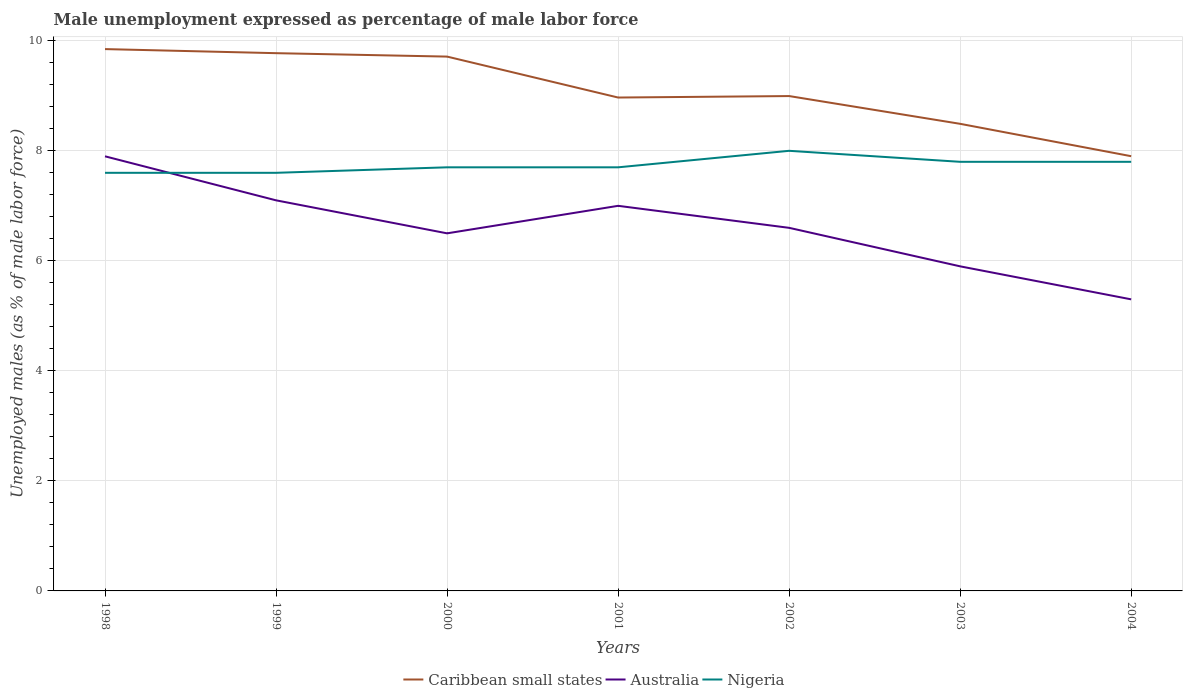How many different coloured lines are there?
Offer a terse response. 3. Is the number of lines equal to the number of legend labels?
Your response must be concise. Yes. Across all years, what is the maximum unemployment in males in in Nigeria?
Provide a short and direct response. 7.6. What is the total unemployment in males in in Caribbean small states in the graph?
Offer a very short reply. 1.22. What is the difference between the highest and the second highest unemployment in males in in Australia?
Offer a very short reply. 2.6. What is the difference between the highest and the lowest unemployment in males in in Nigeria?
Keep it short and to the point. 3. Is the unemployment in males in in Australia strictly greater than the unemployment in males in in Nigeria over the years?
Provide a succinct answer. No. How many lines are there?
Provide a short and direct response. 3. How many years are there in the graph?
Your response must be concise. 7. What is the difference between two consecutive major ticks on the Y-axis?
Provide a succinct answer. 2. Are the values on the major ticks of Y-axis written in scientific E-notation?
Make the answer very short. No. Does the graph contain any zero values?
Provide a short and direct response. No. Where does the legend appear in the graph?
Offer a terse response. Bottom center. How many legend labels are there?
Offer a very short reply. 3. What is the title of the graph?
Make the answer very short. Male unemployment expressed as percentage of male labor force. Does "Uzbekistan" appear as one of the legend labels in the graph?
Make the answer very short. No. What is the label or title of the Y-axis?
Make the answer very short. Unemployed males (as % of male labor force). What is the Unemployed males (as % of male labor force) in Caribbean small states in 1998?
Provide a succinct answer. 9.85. What is the Unemployed males (as % of male labor force) in Australia in 1998?
Provide a succinct answer. 7.9. What is the Unemployed males (as % of male labor force) in Nigeria in 1998?
Offer a terse response. 7.6. What is the Unemployed males (as % of male labor force) of Caribbean small states in 1999?
Keep it short and to the point. 9.77. What is the Unemployed males (as % of male labor force) of Australia in 1999?
Ensure brevity in your answer.  7.1. What is the Unemployed males (as % of male labor force) in Nigeria in 1999?
Your answer should be very brief. 7.6. What is the Unemployed males (as % of male labor force) in Caribbean small states in 2000?
Your answer should be very brief. 9.71. What is the Unemployed males (as % of male labor force) of Australia in 2000?
Provide a succinct answer. 6.5. What is the Unemployed males (as % of male labor force) in Nigeria in 2000?
Offer a terse response. 7.7. What is the Unemployed males (as % of male labor force) of Caribbean small states in 2001?
Your answer should be very brief. 8.97. What is the Unemployed males (as % of male labor force) of Nigeria in 2001?
Your answer should be compact. 7.7. What is the Unemployed males (as % of male labor force) of Caribbean small states in 2002?
Your response must be concise. 9. What is the Unemployed males (as % of male labor force) of Australia in 2002?
Provide a succinct answer. 6.6. What is the Unemployed males (as % of male labor force) of Nigeria in 2002?
Offer a very short reply. 8. What is the Unemployed males (as % of male labor force) of Caribbean small states in 2003?
Make the answer very short. 8.49. What is the Unemployed males (as % of male labor force) of Australia in 2003?
Offer a very short reply. 5.9. What is the Unemployed males (as % of male labor force) of Nigeria in 2003?
Provide a short and direct response. 7.8. What is the Unemployed males (as % of male labor force) in Caribbean small states in 2004?
Offer a terse response. 7.9. What is the Unemployed males (as % of male labor force) in Australia in 2004?
Offer a very short reply. 5.3. What is the Unemployed males (as % of male labor force) in Nigeria in 2004?
Give a very brief answer. 7.8. Across all years, what is the maximum Unemployed males (as % of male labor force) in Caribbean small states?
Provide a succinct answer. 9.85. Across all years, what is the maximum Unemployed males (as % of male labor force) of Australia?
Your answer should be compact. 7.9. Across all years, what is the maximum Unemployed males (as % of male labor force) in Nigeria?
Ensure brevity in your answer.  8. Across all years, what is the minimum Unemployed males (as % of male labor force) of Caribbean small states?
Offer a terse response. 7.9. Across all years, what is the minimum Unemployed males (as % of male labor force) of Australia?
Ensure brevity in your answer.  5.3. Across all years, what is the minimum Unemployed males (as % of male labor force) in Nigeria?
Your answer should be compact. 7.6. What is the total Unemployed males (as % of male labor force) of Caribbean small states in the graph?
Your answer should be very brief. 63.69. What is the total Unemployed males (as % of male labor force) in Australia in the graph?
Keep it short and to the point. 46.3. What is the total Unemployed males (as % of male labor force) in Nigeria in the graph?
Keep it short and to the point. 54.2. What is the difference between the Unemployed males (as % of male labor force) in Caribbean small states in 1998 and that in 1999?
Your answer should be very brief. 0.07. What is the difference between the Unemployed males (as % of male labor force) in Caribbean small states in 1998 and that in 2000?
Provide a short and direct response. 0.14. What is the difference between the Unemployed males (as % of male labor force) in Australia in 1998 and that in 2000?
Give a very brief answer. 1.4. What is the difference between the Unemployed males (as % of male labor force) of Caribbean small states in 1998 and that in 2001?
Make the answer very short. 0.88. What is the difference between the Unemployed males (as % of male labor force) of Australia in 1998 and that in 2001?
Your answer should be compact. 0.9. What is the difference between the Unemployed males (as % of male labor force) in Nigeria in 1998 and that in 2001?
Ensure brevity in your answer.  -0.1. What is the difference between the Unemployed males (as % of male labor force) of Caribbean small states in 1998 and that in 2002?
Your answer should be very brief. 0.85. What is the difference between the Unemployed males (as % of male labor force) in Australia in 1998 and that in 2002?
Ensure brevity in your answer.  1.3. What is the difference between the Unemployed males (as % of male labor force) in Nigeria in 1998 and that in 2002?
Your response must be concise. -0.4. What is the difference between the Unemployed males (as % of male labor force) of Caribbean small states in 1998 and that in 2003?
Ensure brevity in your answer.  1.36. What is the difference between the Unemployed males (as % of male labor force) of Caribbean small states in 1998 and that in 2004?
Make the answer very short. 1.95. What is the difference between the Unemployed males (as % of male labor force) in Caribbean small states in 1999 and that in 2000?
Make the answer very short. 0.06. What is the difference between the Unemployed males (as % of male labor force) in Nigeria in 1999 and that in 2000?
Your answer should be very brief. -0.1. What is the difference between the Unemployed males (as % of male labor force) in Caribbean small states in 1999 and that in 2001?
Your response must be concise. 0.81. What is the difference between the Unemployed males (as % of male labor force) of Australia in 1999 and that in 2001?
Offer a terse response. 0.1. What is the difference between the Unemployed males (as % of male labor force) of Nigeria in 1999 and that in 2001?
Your response must be concise. -0.1. What is the difference between the Unemployed males (as % of male labor force) in Caribbean small states in 1999 and that in 2002?
Your answer should be compact. 0.78. What is the difference between the Unemployed males (as % of male labor force) in Nigeria in 1999 and that in 2002?
Ensure brevity in your answer.  -0.4. What is the difference between the Unemployed males (as % of male labor force) of Caribbean small states in 1999 and that in 2003?
Ensure brevity in your answer.  1.28. What is the difference between the Unemployed males (as % of male labor force) in Caribbean small states in 1999 and that in 2004?
Give a very brief answer. 1.87. What is the difference between the Unemployed males (as % of male labor force) of Australia in 1999 and that in 2004?
Give a very brief answer. 1.8. What is the difference between the Unemployed males (as % of male labor force) of Nigeria in 1999 and that in 2004?
Ensure brevity in your answer.  -0.2. What is the difference between the Unemployed males (as % of male labor force) of Caribbean small states in 2000 and that in 2001?
Ensure brevity in your answer.  0.74. What is the difference between the Unemployed males (as % of male labor force) in Australia in 2000 and that in 2001?
Your answer should be very brief. -0.5. What is the difference between the Unemployed males (as % of male labor force) of Nigeria in 2000 and that in 2001?
Provide a short and direct response. 0. What is the difference between the Unemployed males (as % of male labor force) of Caribbean small states in 2000 and that in 2002?
Ensure brevity in your answer.  0.72. What is the difference between the Unemployed males (as % of male labor force) in Australia in 2000 and that in 2002?
Ensure brevity in your answer.  -0.1. What is the difference between the Unemployed males (as % of male labor force) of Caribbean small states in 2000 and that in 2003?
Ensure brevity in your answer.  1.22. What is the difference between the Unemployed males (as % of male labor force) of Caribbean small states in 2000 and that in 2004?
Give a very brief answer. 1.81. What is the difference between the Unemployed males (as % of male labor force) in Australia in 2000 and that in 2004?
Offer a very short reply. 1.2. What is the difference between the Unemployed males (as % of male labor force) in Caribbean small states in 2001 and that in 2002?
Offer a terse response. -0.03. What is the difference between the Unemployed males (as % of male labor force) of Caribbean small states in 2001 and that in 2003?
Give a very brief answer. 0.48. What is the difference between the Unemployed males (as % of male labor force) in Nigeria in 2001 and that in 2003?
Your response must be concise. -0.1. What is the difference between the Unemployed males (as % of male labor force) in Caribbean small states in 2001 and that in 2004?
Your answer should be compact. 1.07. What is the difference between the Unemployed males (as % of male labor force) in Australia in 2001 and that in 2004?
Make the answer very short. 1.7. What is the difference between the Unemployed males (as % of male labor force) in Caribbean small states in 2002 and that in 2003?
Offer a very short reply. 0.5. What is the difference between the Unemployed males (as % of male labor force) of Australia in 2002 and that in 2003?
Give a very brief answer. 0.7. What is the difference between the Unemployed males (as % of male labor force) in Caribbean small states in 2002 and that in 2004?
Your answer should be compact. 1.09. What is the difference between the Unemployed males (as % of male labor force) in Caribbean small states in 2003 and that in 2004?
Give a very brief answer. 0.59. What is the difference between the Unemployed males (as % of male labor force) in Nigeria in 2003 and that in 2004?
Provide a short and direct response. 0. What is the difference between the Unemployed males (as % of male labor force) of Caribbean small states in 1998 and the Unemployed males (as % of male labor force) of Australia in 1999?
Your response must be concise. 2.75. What is the difference between the Unemployed males (as % of male labor force) in Caribbean small states in 1998 and the Unemployed males (as % of male labor force) in Nigeria in 1999?
Give a very brief answer. 2.25. What is the difference between the Unemployed males (as % of male labor force) of Australia in 1998 and the Unemployed males (as % of male labor force) of Nigeria in 1999?
Make the answer very short. 0.3. What is the difference between the Unemployed males (as % of male labor force) in Caribbean small states in 1998 and the Unemployed males (as % of male labor force) in Australia in 2000?
Your answer should be very brief. 3.35. What is the difference between the Unemployed males (as % of male labor force) of Caribbean small states in 1998 and the Unemployed males (as % of male labor force) of Nigeria in 2000?
Provide a succinct answer. 2.15. What is the difference between the Unemployed males (as % of male labor force) in Caribbean small states in 1998 and the Unemployed males (as % of male labor force) in Australia in 2001?
Offer a terse response. 2.85. What is the difference between the Unemployed males (as % of male labor force) of Caribbean small states in 1998 and the Unemployed males (as % of male labor force) of Nigeria in 2001?
Offer a very short reply. 2.15. What is the difference between the Unemployed males (as % of male labor force) of Australia in 1998 and the Unemployed males (as % of male labor force) of Nigeria in 2001?
Your answer should be compact. 0.2. What is the difference between the Unemployed males (as % of male labor force) in Caribbean small states in 1998 and the Unemployed males (as % of male labor force) in Australia in 2002?
Provide a short and direct response. 3.25. What is the difference between the Unemployed males (as % of male labor force) of Caribbean small states in 1998 and the Unemployed males (as % of male labor force) of Nigeria in 2002?
Your answer should be compact. 1.85. What is the difference between the Unemployed males (as % of male labor force) in Caribbean small states in 1998 and the Unemployed males (as % of male labor force) in Australia in 2003?
Make the answer very short. 3.95. What is the difference between the Unemployed males (as % of male labor force) of Caribbean small states in 1998 and the Unemployed males (as % of male labor force) of Nigeria in 2003?
Make the answer very short. 2.05. What is the difference between the Unemployed males (as % of male labor force) in Australia in 1998 and the Unemployed males (as % of male labor force) in Nigeria in 2003?
Ensure brevity in your answer.  0.1. What is the difference between the Unemployed males (as % of male labor force) of Caribbean small states in 1998 and the Unemployed males (as % of male labor force) of Australia in 2004?
Give a very brief answer. 4.55. What is the difference between the Unemployed males (as % of male labor force) in Caribbean small states in 1998 and the Unemployed males (as % of male labor force) in Nigeria in 2004?
Give a very brief answer. 2.05. What is the difference between the Unemployed males (as % of male labor force) of Caribbean small states in 1999 and the Unemployed males (as % of male labor force) of Australia in 2000?
Your response must be concise. 3.27. What is the difference between the Unemployed males (as % of male labor force) in Caribbean small states in 1999 and the Unemployed males (as % of male labor force) in Nigeria in 2000?
Your response must be concise. 2.07. What is the difference between the Unemployed males (as % of male labor force) of Australia in 1999 and the Unemployed males (as % of male labor force) of Nigeria in 2000?
Your answer should be compact. -0.6. What is the difference between the Unemployed males (as % of male labor force) in Caribbean small states in 1999 and the Unemployed males (as % of male labor force) in Australia in 2001?
Your answer should be very brief. 2.77. What is the difference between the Unemployed males (as % of male labor force) in Caribbean small states in 1999 and the Unemployed males (as % of male labor force) in Nigeria in 2001?
Your answer should be compact. 2.07. What is the difference between the Unemployed males (as % of male labor force) of Caribbean small states in 1999 and the Unemployed males (as % of male labor force) of Australia in 2002?
Offer a terse response. 3.17. What is the difference between the Unemployed males (as % of male labor force) in Caribbean small states in 1999 and the Unemployed males (as % of male labor force) in Nigeria in 2002?
Offer a very short reply. 1.77. What is the difference between the Unemployed males (as % of male labor force) in Australia in 1999 and the Unemployed males (as % of male labor force) in Nigeria in 2002?
Your answer should be compact. -0.9. What is the difference between the Unemployed males (as % of male labor force) in Caribbean small states in 1999 and the Unemployed males (as % of male labor force) in Australia in 2003?
Your response must be concise. 3.87. What is the difference between the Unemployed males (as % of male labor force) of Caribbean small states in 1999 and the Unemployed males (as % of male labor force) of Nigeria in 2003?
Keep it short and to the point. 1.97. What is the difference between the Unemployed males (as % of male labor force) in Australia in 1999 and the Unemployed males (as % of male labor force) in Nigeria in 2003?
Provide a short and direct response. -0.7. What is the difference between the Unemployed males (as % of male labor force) in Caribbean small states in 1999 and the Unemployed males (as % of male labor force) in Australia in 2004?
Give a very brief answer. 4.47. What is the difference between the Unemployed males (as % of male labor force) in Caribbean small states in 1999 and the Unemployed males (as % of male labor force) in Nigeria in 2004?
Ensure brevity in your answer.  1.97. What is the difference between the Unemployed males (as % of male labor force) in Caribbean small states in 2000 and the Unemployed males (as % of male labor force) in Australia in 2001?
Ensure brevity in your answer.  2.71. What is the difference between the Unemployed males (as % of male labor force) in Caribbean small states in 2000 and the Unemployed males (as % of male labor force) in Nigeria in 2001?
Your answer should be very brief. 2.01. What is the difference between the Unemployed males (as % of male labor force) of Australia in 2000 and the Unemployed males (as % of male labor force) of Nigeria in 2001?
Your answer should be compact. -1.2. What is the difference between the Unemployed males (as % of male labor force) of Caribbean small states in 2000 and the Unemployed males (as % of male labor force) of Australia in 2002?
Your response must be concise. 3.11. What is the difference between the Unemployed males (as % of male labor force) in Caribbean small states in 2000 and the Unemployed males (as % of male labor force) in Nigeria in 2002?
Give a very brief answer. 1.71. What is the difference between the Unemployed males (as % of male labor force) of Australia in 2000 and the Unemployed males (as % of male labor force) of Nigeria in 2002?
Give a very brief answer. -1.5. What is the difference between the Unemployed males (as % of male labor force) of Caribbean small states in 2000 and the Unemployed males (as % of male labor force) of Australia in 2003?
Give a very brief answer. 3.81. What is the difference between the Unemployed males (as % of male labor force) in Caribbean small states in 2000 and the Unemployed males (as % of male labor force) in Nigeria in 2003?
Your answer should be compact. 1.91. What is the difference between the Unemployed males (as % of male labor force) of Caribbean small states in 2000 and the Unemployed males (as % of male labor force) of Australia in 2004?
Your response must be concise. 4.41. What is the difference between the Unemployed males (as % of male labor force) in Caribbean small states in 2000 and the Unemployed males (as % of male labor force) in Nigeria in 2004?
Ensure brevity in your answer.  1.91. What is the difference between the Unemployed males (as % of male labor force) of Caribbean small states in 2001 and the Unemployed males (as % of male labor force) of Australia in 2002?
Offer a terse response. 2.37. What is the difference between the Unemployed males (as % of male labor force) in Caribbean small states in 2001 and the Unemployed males (as % of male labor force) in Nigeria in 2002?
Provide a succinct answer. 0.97. What is the difference between the Unemployed males (as % of male labor force) in Australia in 2001 and the Unemployed males (as % of male labor force) in Nigeria in 2002?
Provide a succinct answer. -1. What is the difference between the Unemployed males (as % of male labor force) of Caribbean small states in 2001 and the Unemployed males (as % of male labor force) of Australia in 2003?
Your answer should be compact. 3.07. What is the difference between the Unemployed males (as % of male labor force) in Caribbean small states in 2001 and the Unemployed males (as % of male labor force) in Nigeria in 2003?
Your answer should be compact. 1.17. What is the difference between the Unemployed males (as % of male labor force) of Australia in 2001 and the Unemployed males (as % of male labor force) of Nigeria in 2003?
Provide a succinct answer. -0.8. What is the difference between the Unemployed males (as % of male labor force) in Caribbean small states in 2001 and the Unemployed males (as % of male labor force) in Australia in 2004?
Provide a short and direct response. 3.67. What is the difference between the Unemployed males (as % of male labor force) in Caribbean small states in 2001 and the Unemployed males (as % of male labor force) in Nigeria in 2004?
Your response must be concise. 1.17. What is the difference between the Unemployed males (as % of male labor force) in Caribbean small states in 2002 and the Unemployed males (as % of male labor force) in Australia in 2003?
Offer a terse response. 3.1. What is the difference between the Unemployed males (as % of male labor force) in Caribbean small states in 2002 and the Unemployed males (as % of male labor force) in Nigeria in 2003?
Provide a succinct answer. 1.2. What is the difference between the Unemployed males (as % of male labor force) in Caribbean small states in 2002 and the Unemployed males (as % of male labor force) in Australia in 2004?
Offer a terse response. 3.7. What is the difference between the Unemployed males (as % of male labor force) of Caribbean small states in 2002 and the Unemployed males (as % of male labor force) of Nigeria in 2004?
Your answer should be very brief. 1.2. What is the difference between the Unemployed males (as % of male labor force) in Australia in 2002 and the Unemployed males (as % of male labor force) in Nigeria in 2004?
Your answer should be compact. -1.2. What is the difference between the Unemployed males (as % of male labor force) of Caribbean small states in 2003 and the Unemployed males (as % of male labor force) of Australia in 2004?
Provide a short and direct response. 3.19. What is the difference between the Unemployed males (as % of male labor force) in Caribbean small states in 2003 and the Unemployed males (as % of male labor force) in Nigeria in 2004?
Offer a very short reply. 0.69. What is the average Unemployed males (as % of male labor force) of Caribbean small states per year?
Your answer should be very brief. 9.1. What is the average Unemployed males (as % of male labor force) of Australia per year?
Ensure brevity in your answer.  6.61. What is the average Unemployed males (as % of male labor force) of Nigeria per year?
Provide a short and direct response. 7.74. In the year 1998, what is the difference between the Unemployed males (as % of male labor force) in Caribbean small states and Unemployed males (as % of male labor force) in Australia?
Provide a short and direct response. 1.95. In the year 1998, what is the difference between the Unemployed males (as % of male labor force) in Caribbean small states and Unemployed males (as % of male labor force) in Nigeria?
Make the answer very short. 2.25. In the year 1998, what is the difference between the Unemployed males (as % of male labor force) of Australia and Unemployed males (as % of male labor force) of Nigeria?
Offer a terse response. 0.3. In the year 1999, what is the difference between the Unemployed males (as % of male labor force) of Caribbean small states and Unemployed males (as % of male labor force) of Australia?
Ensure brevity in your answer.  2.67. In the year 1999, what is the difference between the Unemployed males (as % of male labor force) of Caribbean small states and Unemployed males (as % of male labor force) of Nigeria?
Provide a succinct answer. 2.17. In the year 2000, what is the difference between the Unemployed males (as % of male labor force) of Caribbean small states and Unemployed males (as % of male labor force) of Australia?
Offer a very short reply. 3.21. In the year 2000, what is the difference between the Unemployed males (as % of male labor force) of Caribbean small states and Unemployed males (as % of male labor force) of Nigeria?
Provide a short and direct response. 2.01. In the year 2000, what is the difference between the Unemployed males (as % of male labor force) in Australia and Unemployed males (as % of male labor force) in Nigeria?
Keep it short and to the point. -1.2. In the year 2001, what is the difference between the Unemployed males (as % of male labor force) of Caribbean small states and Unemployed males (as % of male labor force) of Australia?
Ensure brevity in your answer.  1.97. In the year 2001, what is the difference between the Unemployed males (as % of male labor force) in Caribbean small states and Unemployed males (as % of male labor force) in Nigeria?
Provide a short and direct response. 1.27. In the year 2001, what is the difference between the Unemployed males (as % of male labor force) of Australia and Unemployed males (as % of male labor force) of Nigeria?
Offer a terse response. -0.7. In the year 2002, what is the difference between the Unemployed males (as % of male labor force) of Caribbean small states and Unemployed males (as % of male labor force) of Australia?
Offer a very short reply. 2.4. In the year 2002, what is the difference between the Unemployed males (as % of male labor force) of Caribbean small states and Unemployed males (as % of male labor force) of Nigeria?
Your answer should be very brief. 1. In the year 2003, what is the difference between the Unemployed males (as % of male labor force) of Caribbean small states and Unemployed males (as % of male labor force) of Australia?
Offer a terse response. 2.59. In the year 2003, what is the difference between the Unemployed males (as % of male labor force) in Caribbean small states and Unemployed males (as % of male labor force) in Nigeria?
Give a very brief answer. 0.69. In the year 2003, what is the difference between the Unemployed males (as % of male labor force) of Australia and Unemployed males (as % of male labor force) of Nigeria?
Provide a short and direct response. -1.9. In the year 2004, what is the difference between the Unemployed males (as % of male labor force) in Caribbean small states and Unemployed males (as % of male labor force) in Australia?
Your answer should be compact. 2.6. In the year 2004, what is the difference between the Unemployed males (as % of male labor force) of Caribbean small states and Unemployed males (as % of male labor force) of Nigeria?
Ensure brevity in your answer.  0.1. In the year 2004, what is the difference between the Unemployed males (as % of male labor force) in Australia and Unemployed males (as % of male labor force) in Nigeria?
Provide a short and direct response. -2.5. What is the ratio of the Unemployed males (as % of male labor force) in Caribbean small states in 1998 to that in 1999?
Give a very brief answer. 1.01. What is the ratio of the Unemployed males (as % of male labor force) in Australia in 1998 to that in 1999?
Your answer should be compact. 1.11. What is the ratio of the Unemployed males (as % of male labor force) of Nigeria in 1998 to that in 1999?
Your answer should be very brief. 1. What is the ratio of the Unemployed males (as % of male labor force) in Australia in 1998 to that in 2000?
Keep it short and to the point. 1.22. What is the ratio of the Unemployed males (as % of male labor force) in Nigeria in 1998 to that in 2000?
Keep it short and to the point. 0.99. What is the ratio of the Unemployed males (as % of male labor force) in Caribbean small states in 1998 to that in 2001?
Your answer should be compact. 1.1. What is the ratio of the Unemployed males (as % of male labor force) in Australia in 1998 to that in 2001?
Offer a very short reply. 1.13. What is the ratio of the Unemployed males (as % of male labor force) of Nigeria in 1998 to that in 2001?
Ensure brevity in your answer.  0.99. What is the ratio of the Unemployed males (as % of male labor force) in Caribbean small states in 1998 to that in 2002?
Offer a very short reply. 1.09. What is the ratio of the Unemployed males (as % of male labor force) of Australia in 1998 to that in 2002?
Make the answer very short. 1.2. What is the ratio of the Unemployed males (as % of male labor force) of Nigeria in 1998 to that in 2002?
Provide a short and direct response. 0.95. What is the ratio of the Unemployed males (as % of male labor force) in Caribbean small states in 1998 to that in 2003?
Make the answer very short. 1.16. What is the ratio of the Unemployed males (as % of male labor force) in Australia in 1998 to that in 2003?
Provide a succinct answer. 1.34. What is the ratio of the Unemployed males (as % of male labor force) in Nigeria in 1998 to that in 2003?
Provide a short and direct response. 0.97. What is the ratio of the Unemployed males (as % of male labor force) in Caribbean small states in 1998 to that in 2004?
Provide a short and direct response. 1.25. What is the ratio of the Unemployed males (as % of male labor force) of Australia in 1998 to that in 2004?
Your response must be concise. 1.49. What is the ratio of the Unemployed males (as % of male labor force) of Nigeria in 1998 to that in 2004?
Provide a succinct answer. 0.97. What is the ratio of the Unemployed males (as % of male labor force) of Caribbean small states in 1999 to that in 2000?
Your answer should be compact. 1.01. What is the ratio of the Unemployed males (as % of male labor force) in Australia in 1999 to that in 2000?
Your response must be concise. 1.09. What is the ratio of the Unemployed males (as % of male labor force) in Nigeria in 1999 to that in 2000?
Provide a succinct answer. 0.99. What is the ratio of the Unemployed males (as % of male labor force) in Caribbean small states in 1999 to that in 2001?
Your answer should be very brief. 1.09. What is the ratio of the Unemployed males (as % of male labor force) in Australia in 1999 to that in 2001?
Give a very brief answer. 1.01. What is the ratio of the Unemployed males (as % of male labor force) in Caribbean small states in 1999 to that in 2002?
Provide a short and direct response. 1.09. What is the ratio of the Unemployed males (as % of male labor force) in Australia in 1999 to that in 2002?
Your response must be concise. 1.08. What is the ratio of the Unemployed males (as % of male labor force) of Nigeria in 1999 to that in 2002?
Keep it short and to the point. 0.95. What is the ratio of the Unemployed males (as % of male labor force) in Caribbean small states in 1999 to that in 2003?
Offer a terse response. 1.15. What is the ratio of the Unemployed males (as % of male labor force) in Australia in 1999 to that in 2003?
Your response must be concise. 1.2. What is the ratio of the Unemployed males (as % of male labor force) of Nigeria in 1999 to that in 2003?
Your answer should be very brief. 0.97. What is the ratio of the Unemployed males (as % of male labor force) of Caribbean small states in 1999 to that in 2004?
Provide a succinct answer. 1.24. What is the ratio of the Unemployed males (as % of male labor force) of Australia in 1999 to that in 2004?
Your answer should be very brief. 1.34. What is the ratio of the Unemployed males (as % of male labor force) of Nigeria in 1999 to that in 2004?
Keep it short and to the point. 0.97. What is the ratio of the Unemployed males (as % of male labor force) in Caribbean small states in 2000 to that in 2001?
Keep it short and to the point. 1.08. What is the ratio of the Unemployed males (as % of male labor force) of Australia in 2000 to that in 2001?
Ensure brevity in your answer.  0.93. What is the ratio of the Unemployed males (as % of male labor force) in Nigeria in 2000 to that in 2001?
Your answer should be compact. 1. What is the ratio of the Unemployed males (as % of male labor force) of Caribbean small states in 2000 to that in 2002?
Offer a terse response. 1.08. What is the ratio of the Unemployed males (as % of male labor force) of Australia in 2000 to that in 2002?
Your answer should be compact. 0.98. What is the ratio of the Unemployed males (as % of male labor force) of Nigeria in 2000 to that in 2002?
Your answer should be very brief. 0.96. What is the ratio of the Unemployed males (as % of male labor force) of Caribbean small states in 2000 to that in 2003?
Your answer should be very brief. 1.14. What is the ratio of the Unemployed males (as % of male labor force) of Australia in 2000 to that in 2003?
Make the answer very short. 1.1. What is the ratio of the Unemployed males (as % of male labor force) in Nigeria in 2000 to that in 2003?
Keep it short and to the point. 0.99. What is the ratio of the Unemployed males (as % of male labor force) in Caribbean small states in 2000 to that in 2004?
Offer a very short reply. 1.23. What is the ratio of the Unemployed males (as % of male labor force) of Australia in 2000 to that in 2004?
Your response must be concise. 1.23. What is the ratio of the Unemployed males (as % of male labor force) in Nigeria in 2000 to that in 2004?
Offer a very short reply. 0.99. What is the ratio of the Unemployed males (as % of male labor force) in Caribbean small states in 2001 to that in 2002?
Ensure brevity in your answer.  1. What is the ratio of the Unemployed males (as % of male labor force) of Australia in 2001 to that in 2002?
Your response must be concise. 1.06. What is the ratio of the Unemployed males (as % of male labor force) of Nigeria in 2001 to that in 2002?
Your answer should be compact. 0.96. What is the ratio of the Unemployed males (as % of male labor force) in Caribbean small states in 2001 to that in 2003?
Your answer should be compact. 1.06. What is the ratio of the Unemployed males (as % of male labor force) in Australia in 2001 to that in 2003?
Offer a terse response. 1.19. What is the ratio of the Unemployed males (as % of male labor force) of Nigeria in 2001 to that in 2003?
Give a very brief answer. 0.99. What is the ratio of the Unemployed males (as % of male labor force) of Caribbean small states in 2001 to that in 2004?
Your answer should be compact. 1.14. What is the ratio of the Unemployed males (as % of male labor force) of Australia in 2001 to that in 2004?
Your answer should be very brief. 1.32. What is the ratio of the Unemployed males (as % of male labor force) of Nigeria in 2001 to that in 2004?
Give a very brief answer. 0.99. What is the ratio of the Unemployed males (as % of male labor force) in Caribbean small states in 2002 to that in 2003?
Give a very brief answer. 1.06. What is the ratio of the Unemployed males (as % of male labor force) in Australia in 2002 to that in 2003?
Keep it short and to the point. 1.12. What is the ratio of the Unemployed males (as % of male labor force) of Nigeria in 2002 to that in 2003?
Make the answer very short. 1.03. What is the ratio of the Unemployed males (as % of male labor force) in Caribbean small states in 2002 to that in 2004?
Offer a very short reply. 1.14. What is the ratio of the Unemployed males (as % of male labor force) of Australia in 2002 to that in 2004?
Ensure brevity in your answer.  1.25. What is the ratio of the Unemployed males (as % of male labor force) in Nigeria in 2002 to that in 2004?
Make the answer very short. 1.03. What is the ratio of the Unemployed males (as % of male labor force) in Caribbean small states in 2003 to that in 2004?
Provide a succinct answer. 1.07. What is the ratio of the Unemployed males (as % of male labor force) of Australia in 2003 to that in 2004?
Offer a very short reply. 1.11. What is the ratio of the Unemployed males (as % of male labor force) of Nigeria in 2003 to that in 2004?
Your answer should be compact. 1. What is the difference between the highest and the second highest Unemployed males (as % of male labor force) in Caribbean small states?
Keep it short and to the point. 0.07. What is the difference between the highest and the second highest Unemployed males (as % of male labor force) in Nigeria?
Give a very brief answer. 0.2. What is the difference between the highest and the lowest Unemployed males (as % of male labor force) in Caribbean small states?
Offer a very short reply. 1.95. What is the difference between the highest and the lowest Unemployed males (as % of male labor force) in Australia?
Provide a short and direct response. 2.6. What is the difference between the highest and the lowest Unemployed males (as % of male labor force) of Nigeria?
Ensure brevity in your answer.  0.4. 